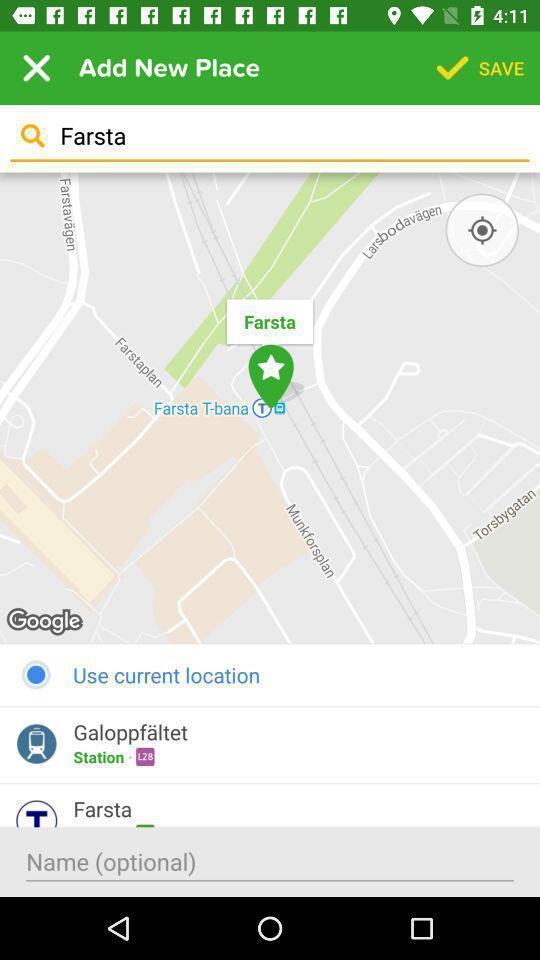Describe this image in words. Page displaying the location finder app. 